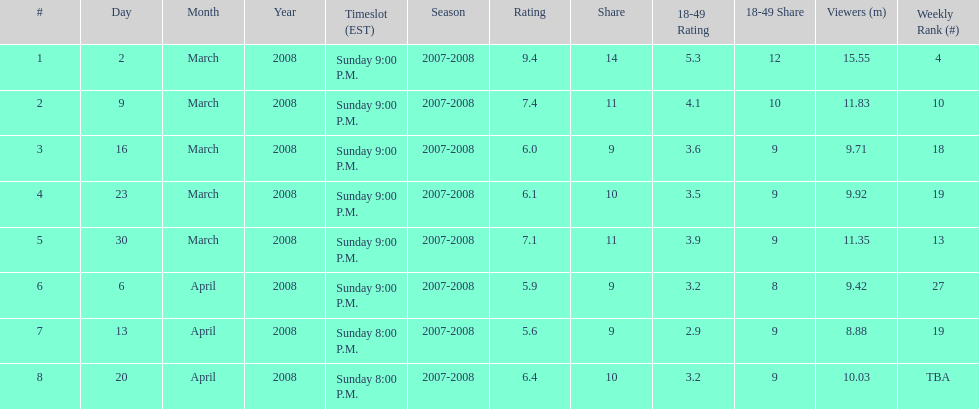Which air date had the least viewers? April 13, 2008. 